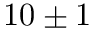Convert formula to latex. <formula><loc_0><loc_0><loc_500><loc_500>1 0 \pm 1</formula> 